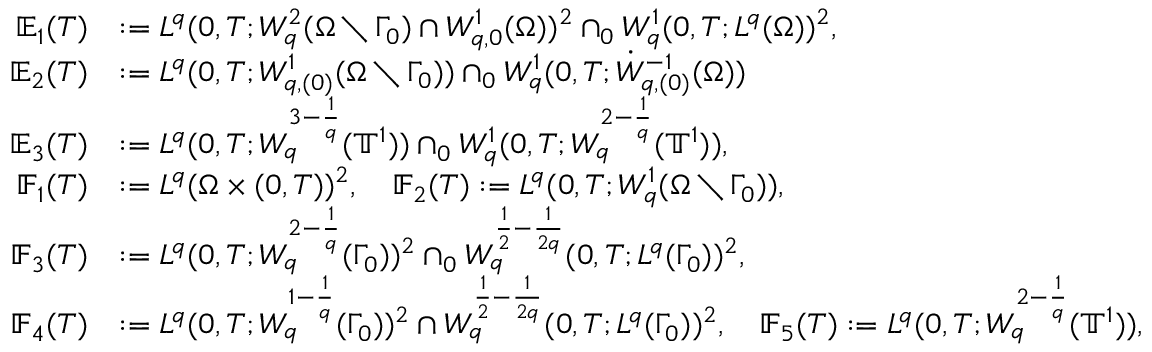Convert formula to latex. <formula><loc_0><loc_0><loc_500><loc_500>\begin{array} { r l } { \mathbb { E } _ { 1 } ( T ) } & { \colon = L ^ { q } ( 0 , T ; W _ { q } ^ { 2 } ( \Omega \ \Gamma _ { 0 } ) \cap W _ { q , 0 } ^ { 1 } ( \Omega ) ) ^ { 2 } \cap _ { 0 } W _ { q } ^ { 1 } ( 0 , T ; L ^ { q } ( \Omega ) ) ^ { 2 } , } \\ { \mathbb { E } _ { 2 } ( T ) } & { \colon = L ^ { q } ( 0 , T ; W _ { q , ( 0 ) } ^ { 1 } ( \Omega \ \Gamma _ { 0 } ) ) \cap _ { 0 } W _ { q } ^ { 1 } ( 0 , T ; \dot { W } _ { q , ( 0 ) } ^ { - 1 } ( \Omega ) ) } \\ { \mathbb { E } _ { 3 } ( T ) } & { \colon = L ^ { q } ( 0 , T ; W _ { q } ^ { 3 - \frac { 1 } { q } } ( { \mathbb { T } } ^ { 1 } ) ) \cap _ { 0 } W _ { q } ^ { 1 } ( 0 , T ; W _ { q } ^ { 2 - \frac { 1 } { q } } ( { \mathbb { T } } ^ { 1 } ) ) , } \\ { \mathbb { F } _ { 1 } ( T ) } & { \colon = L ^ { q } ( \Omega \times ( 0 , T ) ) ^ { 2 } , \quad \mathbb { F } _ { 2 } ( T ) \colon = L ^ { q } ( 0 , T ; W _ { q } ^ { 1 } ( \Omega \ \Gamma _ { 0 } ) ) , } \\ { \mathbb { F } _ { 3 } ( T ) } & { \colon = L ^ { q } ( 0 , T ; W _ { q } ^ { 2 - \frac { 1 } { q } } ( \Gamma _ { 0 } ) ) ^ { 2 } \cap _ { 0 } W _ { q } ^ { \frac { 1 } { 2 } - \frac { 1 } 2 q } } ( 0 , T ; L ^ { q } ( \Gamma _ { 0 } ) ) ^ { 2 } , \quad } \\ { \mathbb { F } _ { 4 } ( T ) } & { \colon = L ^ { q } ( 0 , T ; W _ { q } ^ { 1 - \frac { 1 } { q } } ( \Gamma _ { 0 } ) ) ^ { 2 } \cap W _ { q } ^ { \frac { 1 } { 2 } - \frac { 1 } 2 q } } ( 0 , T ; L ^ { q } ( \Gamma _ { 0 } ) ) ^ { 2 } , \quad \mathbb { F } _ { 5 } ( T ) \colon = L ^ { q } ( 0 , T ; W _ { q } ^ { 2 - \frac { 1 } { q } } ( { \mathbb { T } } ^ { 1 } ) ) , } \end{array}</formula> 